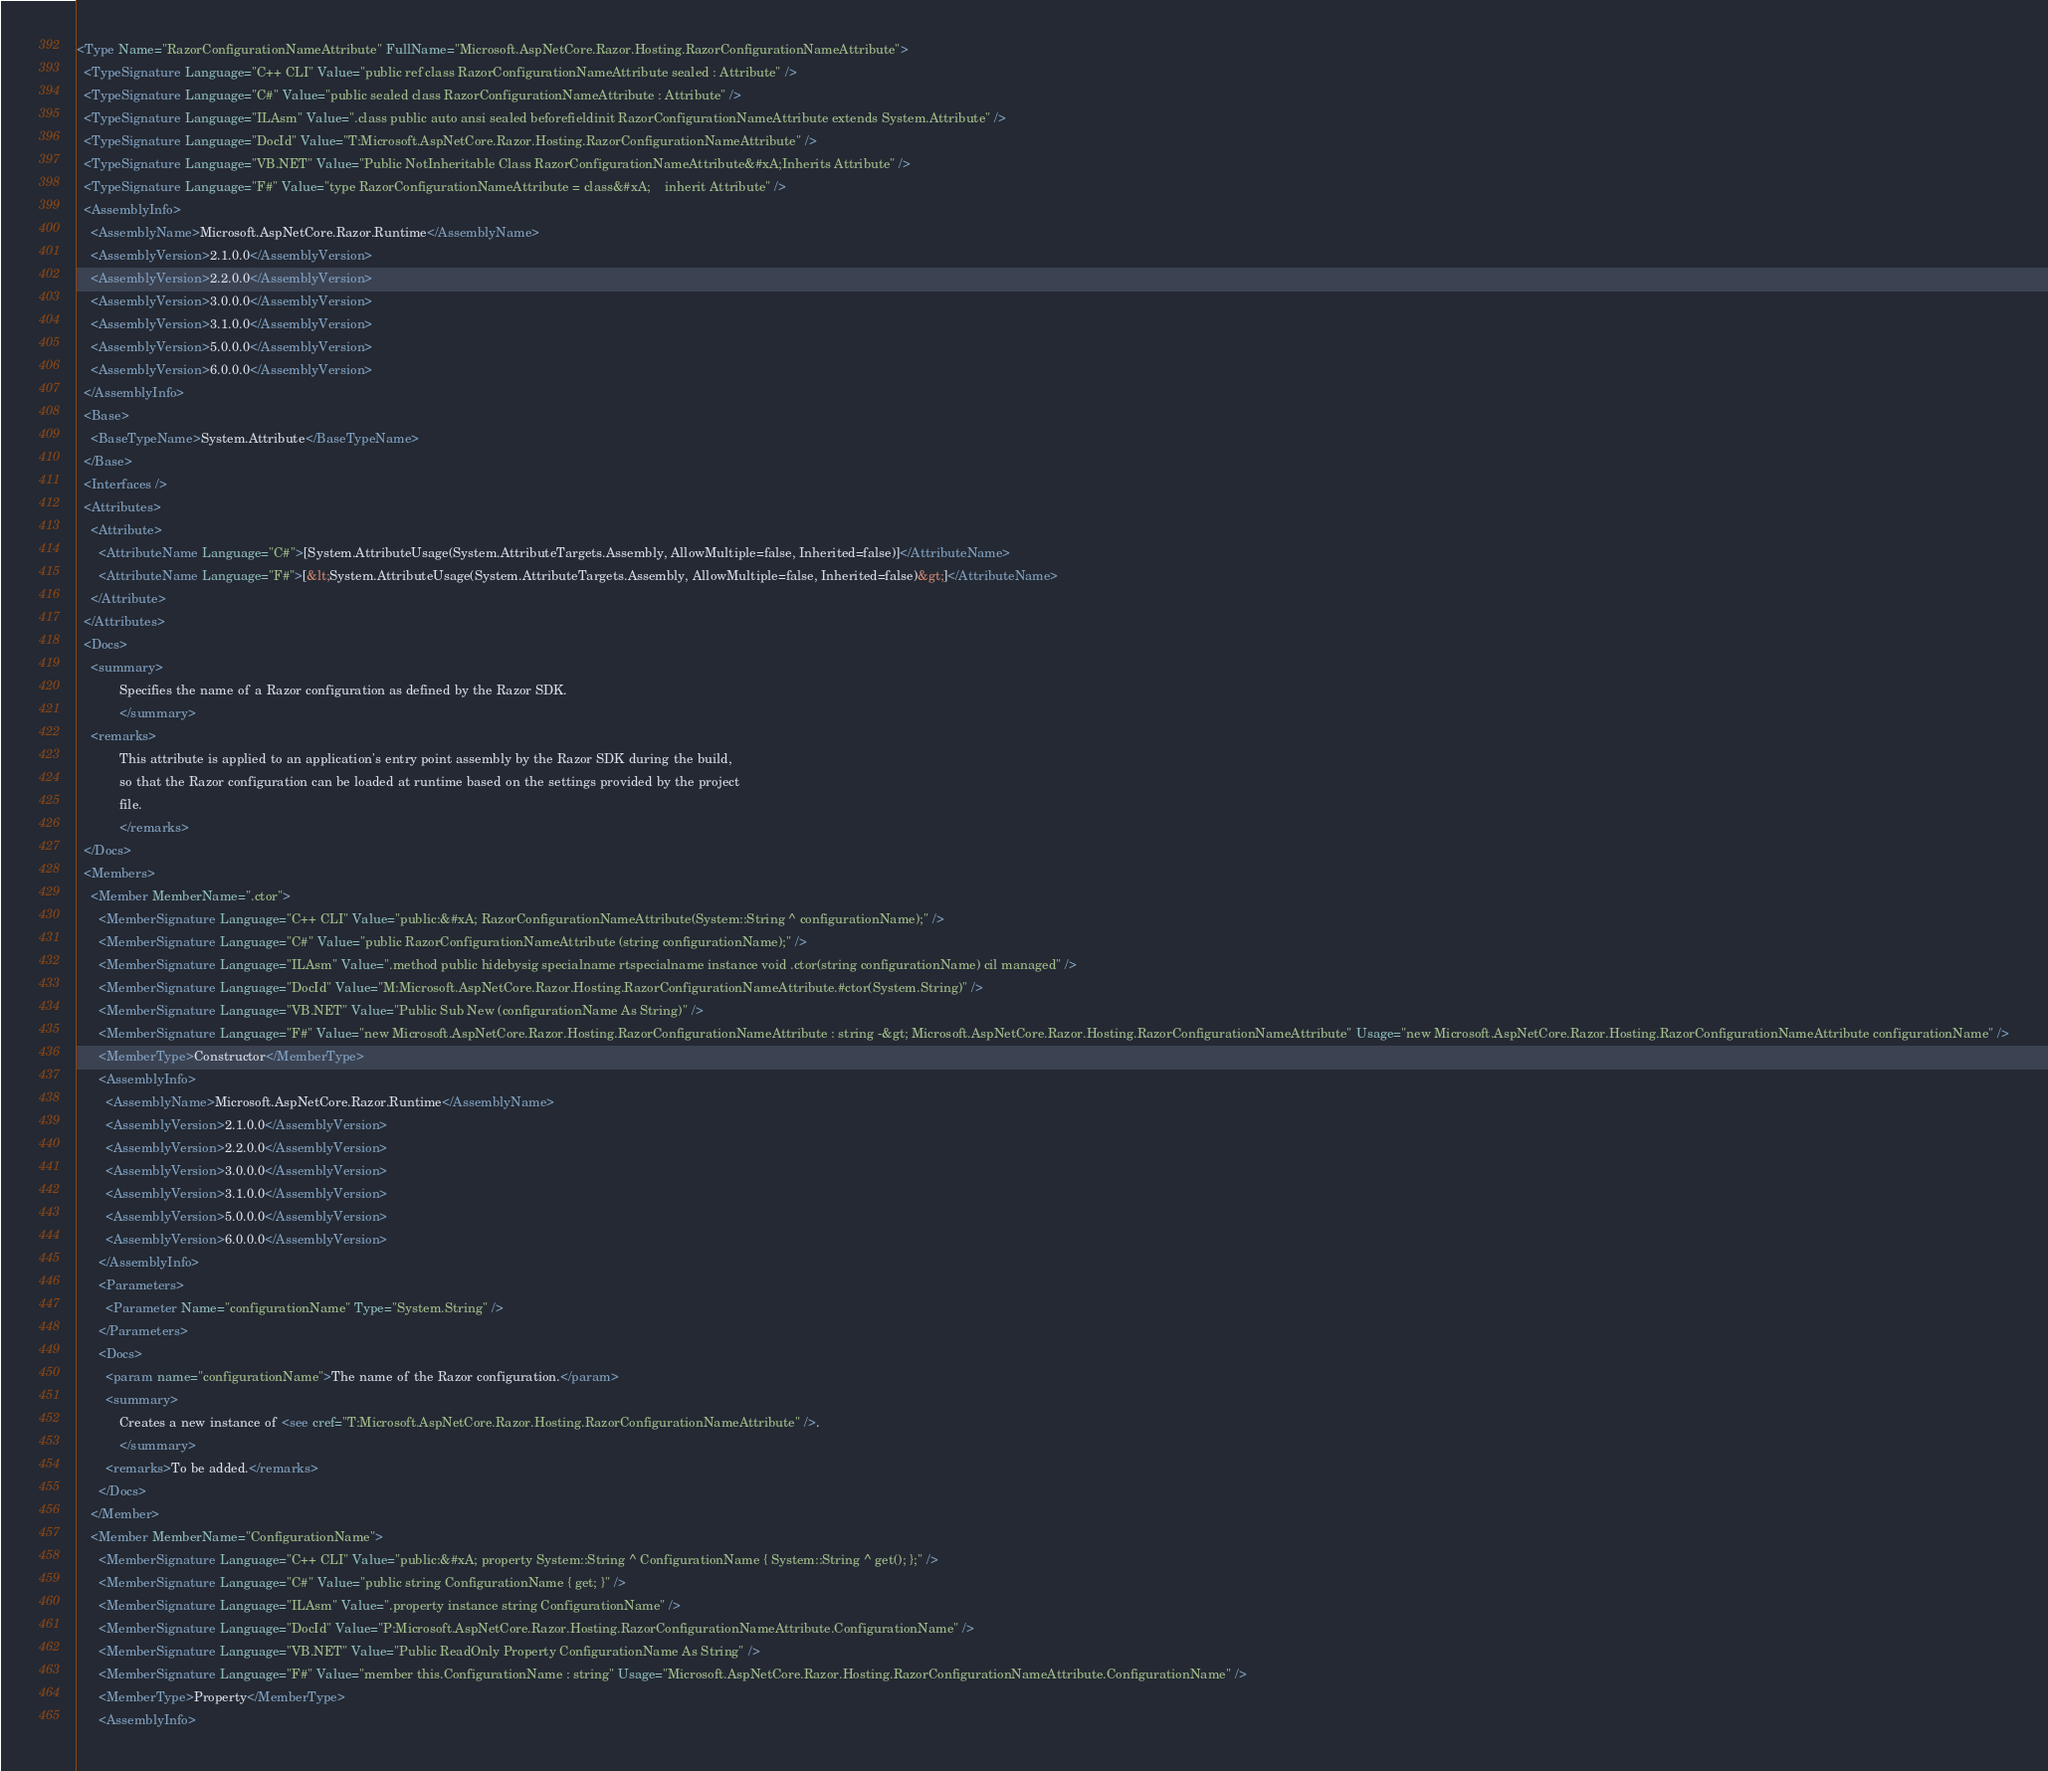Convert code to text. <code><loc_0><loc_0><loc_500><loc_500><_XML_><Type Name="RazorConfigurationNameAttribute" FullName="Microsoft.AspNetCore.Razor.Hosting.RazorConfigurationNameAttribute">
  <TypeSignature Language="C++ CLI" Value="public ref class RazorConfigurationNameAttribute sealed : Attribute" />
  <TypeSignature Language="C#" Value="public sealed class RazorConfigurationNameAttribute : Attribute" />
  <TypeSignature Language="ILAsm" Value=".class public auto ansi sealed beforefieldinit RazorConfigurationNameAttribute extends System.Attribute" />
  <TypeSignature Language="DocId" Value="T:Microsoft.AspNetCore.Razor.Hosting.RazorConfigurationNameAttribute" />
  <TypeSignature Language="VB.NET" Value="Public NotInheritable Class RazorConfigurationNameAttribute&#xA;Inherits Attribute" />
  <TypeSignature Language="F#" Value="type RazorConfigurationNameAttribute = class&#xA;    inherit Attribute" />
  <AssemblyInfo>
    <AssemblyName>Microsoft.AspNetCore.Razor.Runtime</AssemblyName>
    <AssemblyVersion>2.1.0.0</AssemblyVersion>
    <AssemblyVersion>2.2.0.0</AssemblyVersion>
    <AssemblyVersion>3.0.0.0</AssemblyVersion>
    <AssemblyVersion>3.1.0.0</AssemblyVersion>
    <AssemblyVersion>5.0.0.0</AssemblyVersion>
    <AssemblyVersion>6.0.0.0</AssemblyVersion>
  </AssemblyInfo>
  <Base>
    <BaseTypeName>System.Attribute</BaseTypeName>
  </Base>
  <Interfaces />
  <Attributes>
    <Attribute>
      <AttributeName Language="C#">[System.AttributeUsage(System.AttributeTargets.Assembly, AllowMultiple=false, Inherited=false)]</AttributeName>
      <AttributeName Language="F#">[&lt;System.AttributeUsage(System.AttributeTargets.Assembly, AllowMultiple=false, Inherited=false)&gt;]</AttributeName>
    </Attribute>
  </Attributes>
  <Docs>
    <summary>
            Specifies the name of a Razor configuration as defined by the Razor SDK.
            </summary>
    <remarks>
            This attribute is applied to an application's entry point assembly by the Razor SDK during the build,
            so that the Razor configuration can be loaded at runtime based on the settings provided by the project
            file.
            </remarks>
  </Docs>
  <Members>
    <Member MemberName=".ctor">
      <MemberSignature Language="C++ CLI" Value="public:&#xA; RazorConfigurationNameAttribute(System::String ^ configurationName);" />
      <MemberSignature Language="C#" Value="public RazorConfigurationNameAttribute (string configurationName);" />
      <MemberSignature Language="ILAsm" Value=".method public hidebysig specialname rtspecialname instance void .ctor(string configurationName) cil managed" />
      <MemberSignature Language="DocId" Value="M:Microsoft.AspNetCore.Razor.Hosting.RazorConfigurationNameAttribute.#ctor(System.String)" />
      <MemberSignature Language="VB.NET" Value="Public Sub New (configurationName As String)" />
      <MemberSignature Language="F#" Value="new Microsoft.AspNetCore.Razor.Hosting.RazorConfigurationNameAttribute : string -&gt; Microsoft.AspNetCore.Razor.Hosting.RazorConfigurationNameAttribute" Usage="new Microsoft.AspNetCore.Razor.Hosting.RazorConfigurationNameAttribute configurationName" />
      <MemberType>Constructor</MemberType>
      <AssemblyInfo>
        <AssemblyName>Microsoft.AspNetCore.Razor.Runtime</AssemblyName>
        <AssemblyVersion>2.1.0.0</AssemblyVersion>
        <AssemblyVersion>2.2.0.0</AssemblyVersion>
        <AssemblyVersion>3.0.0.0</AssemblyVersion>
        <AssemblyVersion>3.1.0.0</AssemblyVersion>
        <AssemblyVersion>5.0.0.0</AssemblyVersion>
        <AssemblyVersion>6.0.0.0</AssemblyVersion>
      </AssemblyInfo>
      <Parameters>
        <Parameter Name="configurationName" Type="System.String" />
      </Parameters>
      <Docs>
        <param name="configurationName">The name of the Razor configuration.</param>
        <summary>
            Creates a new instance of <see cref="T:Microsoft.AspNetCore.Razor.Hosting.RazorConfigurationNameAttribute" />.
            </summary>
        <remarks>To be added.</remarks>
      </Docs>
    </Member>
    <Member MemberName="ConfigurationName">
      <MemberSignature Language="C++ CLI" Value="public:&#xA; property System::String ^ ConfigurationName { System::String ^ get(); };" />
      <MemberSignature Language="C#" Value="public string ConfigurationName { get; }" />
      <MemberSignature Language="ILAsm" Value=".property instance string ConfigurationName" />
      <MemberSignature Language="DocId" Value="P:Microsoft.AspNetCore.Razor.Hosting.RazorConfigurationNameAttribute.ConfigurationName" />
      <MemberSignature Language="VB.NET" Value="Public ReadOnly Property ConfigurationName As String" />
      <MemberSignature Language="F#" Value="member this.ConfigurationName : string" Usage="Microsoft.AspNetCore.Razor.Hosting.RazorConfigurationNameAttribute.ConfigurationName" />
      <MemberType>Property</MemberType>
      <AssemblyInfo></code> 